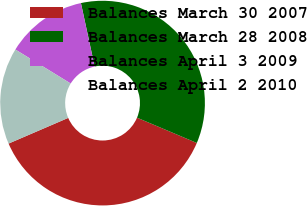Convert chart to OTSL. <chart><loc_0><loc_0><loc_500><loc_500><pie_chart><fcel>Balances March 30 2007<fcel>Balances March 28 2008<fcel>Balances April 3 2009<fcel>Balances April 2 2010<nl><fcel>37.16%<fcel>34.76%<fcel>12.84%<fcel>15.24%<nl></chart> 